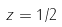Convert formula to latex. <formula><loc_0><loc_0><loc_500><loc_500>z = 1 / 2</formula> 